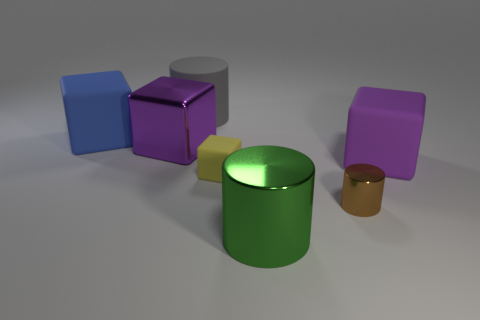How many big gray objects are left of the big gray cylinder on the right side of the large purple thing left of the tiny metal thing?
Your answer should be compact. 0. What color is the big cylinder on the right side of the small rubber block?
Keep it short and to the point. Green. Is the color of the large thing behind the blue matte thing the same as the small matte thing?
Make the answer very short. No. What size is the green metallic thing that is the same shape as the brown shiny object?
Offer a very short reply. Large. Is there any other thing that has the same size as the green metal cylinder?
Your answer should be very brief. Yes. What is the large green thing in front of the big purple object on the right side of the yellow thing to the left of the brown metallic object made of?
Ensure brevity in your answer.  Metal. Is the number of gray rubber objects in front of the large purple shiny object greater than the number of matte things that are behind the yellow object?
Provide a succinct answer. No. Is the size of the blue block the same as the yellow rubber cube?
Your answer should be compact. No. The large metal object that is the same shape as the tiny brown thing is what color?
Provide a short and direct response. Green. How many tiny metallic cylinders have the same color as the small rubber object?
Your answer should be very brief. 0. 